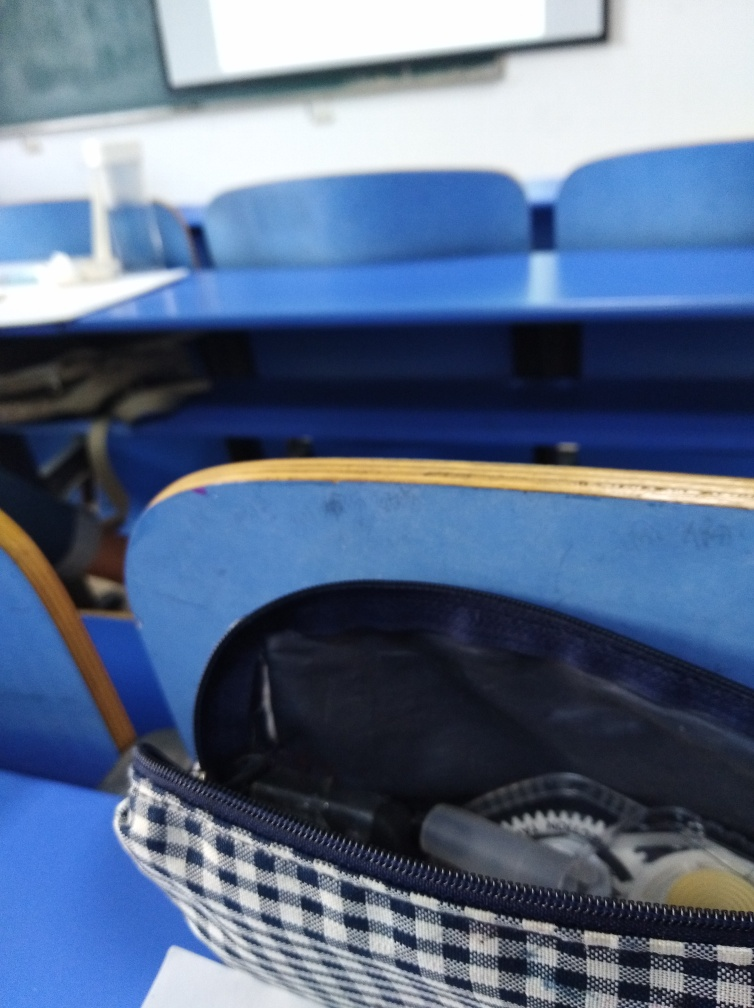What does this image suggest about the activity level in the classroom? There are no people present in the image, which could indicate that the photo was taken during a break, before or after a class session, or possibly during a quiet study period. The absence of activity suggests tranquility for the moment. 